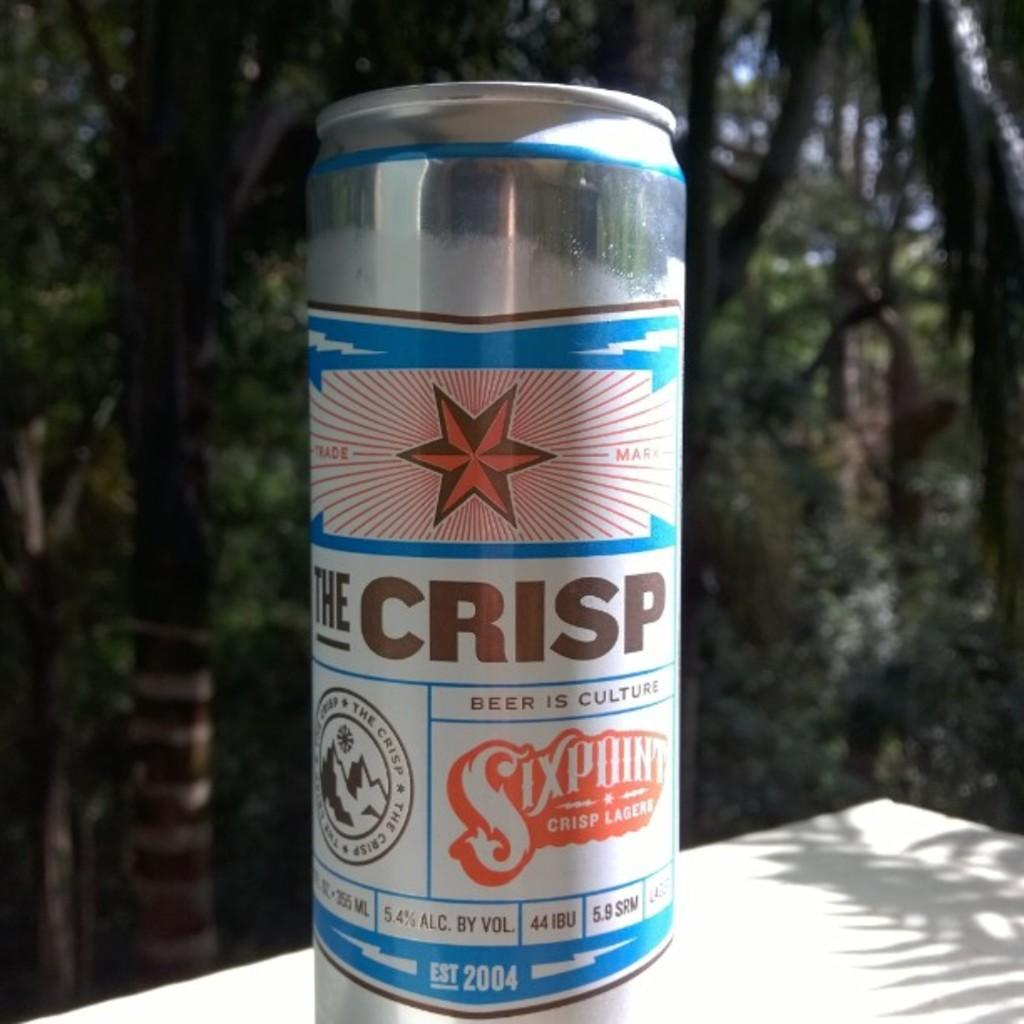Provide a one-sentence caption for the provided image. A can of beer that says The Crisp on it. 